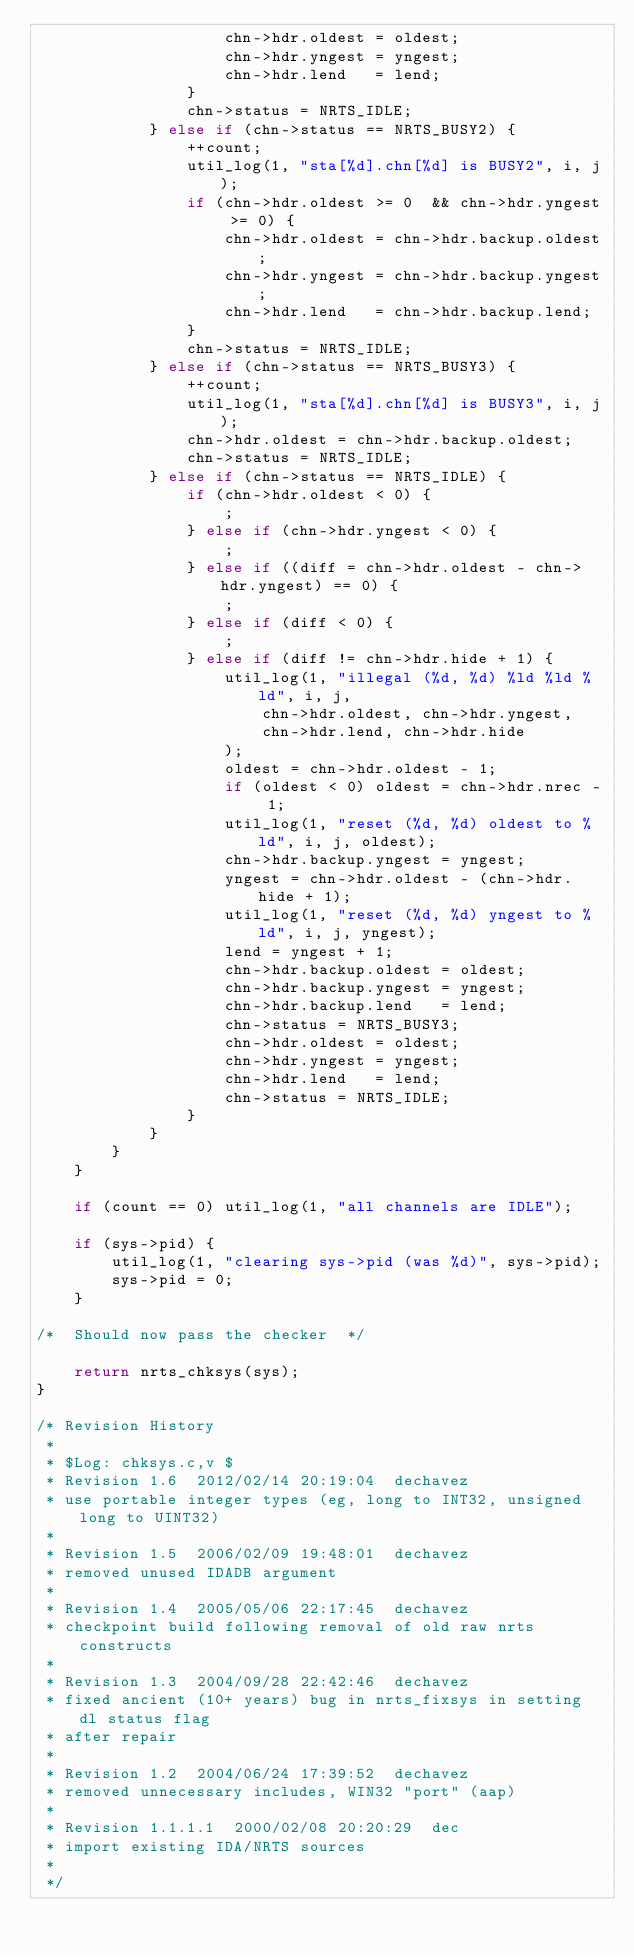Convert code to text. <code><loc_0><loc_0><loc_500><loc_500><_C_>                    chn->hdr.oldest = oldest;
                    chn->hdr.yngest = yngest;
                    chn->hdr.lend   = lend;
                }
                chn->status = NRTS_IDLE;
            } else if (chn->status == NRTS_BUSY2) {
                ++count;
                util_log(1, "sta[%d].chn[%d] is BUSY2", i, j);
                if (chn->hdr.oldest >= 0  && chn->hdr.yngest >= 0) {
                    chn->hdr.oldest = chn->hdr.backup.oldest;
                    chn->hdr.yngest = chn->hdr.backup.yngest;
                    chn->hdr.lend   = chn->hdr.backup.lend;
                }
                chn->status = NRTS_IDLE;
            } else if (chn->status == NRTS_BUSY3) {
                ++count;
                util_log(1, "sta[%d].chn[%d] is BUSY3", i, j);
                chn->hdr.oldest = chn->hdr.backup.oldest;
                chn->status = NRTS_IDLE;
            } else if (chn->status == NRTS_IDLE) {
                if (chn->hdr.oldest < 0) {
                    ;
                } else if (chn->hdr.yngest < 0) {
                    ;
                } else if ((diff = chn->hdr.oldest - chn->hdr.yngest) == 0) {
                    ;
                } else if (diff < 0) {
                    ;
                } else if (diff != chn->hdr.hide + 1) {
                    util_log(1, "illegal (%d, %d) %ld %ld %ld", i, j,
                        chn->hdr.oldest, chn->hdr.yngest,
                        chn->hdr.lend, chn->hdr.hide
                    );
                    oldest = chn->hdr.oldest - 1;
                    if (oldest < 0) oldest = chn->hdr.nrec - 1;
                    util_log(1, "reset (%d, %d) oldest to %ld", i, j, oldest);
                    chn->hdr.backup.yngest = yngest;
                    yngest = chn->hdr.oldest - (chn->hdr.hide + 1);
                    util_log(1, "reset (%d, %d) yngest to %ld", i, j, yngest);
                    lend = yngest + 1;
                    chn->hdr.backup.oldest = oldest;
                    chn->hdr.backup.yngest = yngest;
                    chn->hdr.backup.lend   = lend;
                    chn->status = NRTS_BUSY3;
                    chn->hdr.oldest = oldest;
                    chn->hdr.yngest = yngest;
                    chn->hdr.lend   = lend;
                    chn->status = NRTS_IDLE;
                }
            }
        }
    }

    if (count == 0) util_log(1, "all channels are IDLE");

    if (sys->pid) {
        util_log(1, "clearing sys->pid (was %d)", sys->pid);
        sys->pid = 0;
    }

/*  Should now pass the checker  */

    return nrts_chksys(sys);
}

/* Revision History
 *
 * $Log: chksys.c,v $
 * Revision 1.6  2012/02/14 20:19:04  dechavez
 * use portable integer types (eg, long to INT32, unsigned long to UINT32)
 *
 * Revision 1.5  2006/02/09 19:48:01  dechavez
 * removed unused IDADB argument
 *
 * Revision 1.4  2005/05/06 22:17:45  dechavez
 * checkpoint build following removal of old raw nrts constructs
 *
 * Revision 1.3  2004/09/28 22:42:46  dechavez
 * fixed ancient (10+ years) bug in nrts_fixsys in setting dl status flag
 * after repair
 *
 * Revision 1.2  2004/06/24 17:39:52  dechavez
 * removed unnecessary includes, WIN32 "port" (aap)
 *
 * Revision 1.1.1.1  2000/02/08 20:20:29  dec
 * import existing IDA/NRTS sources
 *
 */
</code> 